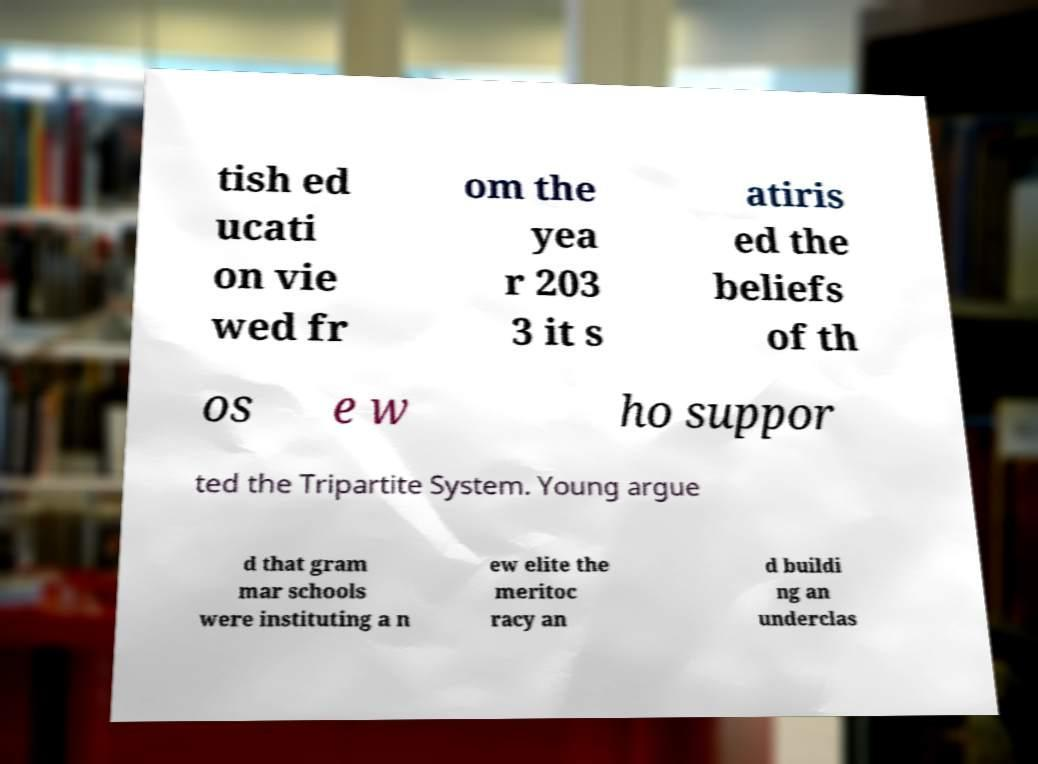Can you accurately transcribe the text from the provided image for me? tish ed ucati on vie wed fr om the yea r 203 3 it s atiris ed the beliefs of th os e w ho suppor ted the Tripartite System. Young argue d that gram mar schools were instituting a n ew elite the meritoc racy an d buildi ng an underclas 